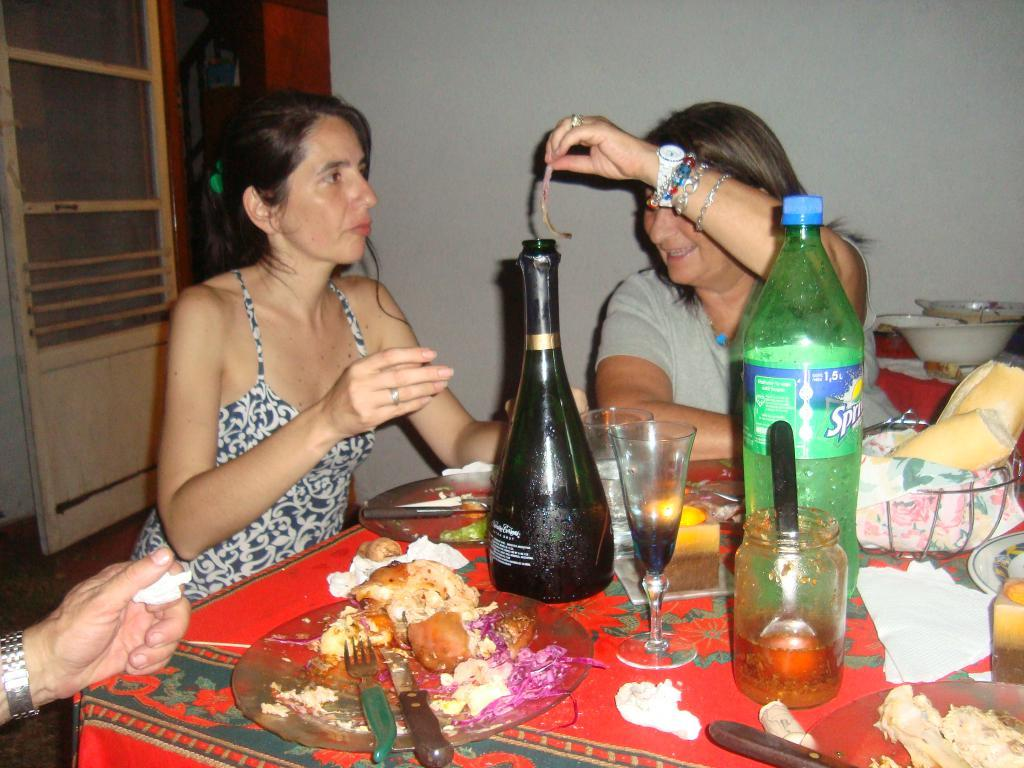<image>
Offer a succinct explanation of the picture presented. Woman putting something in a bottle next to a Sprite bottle. 